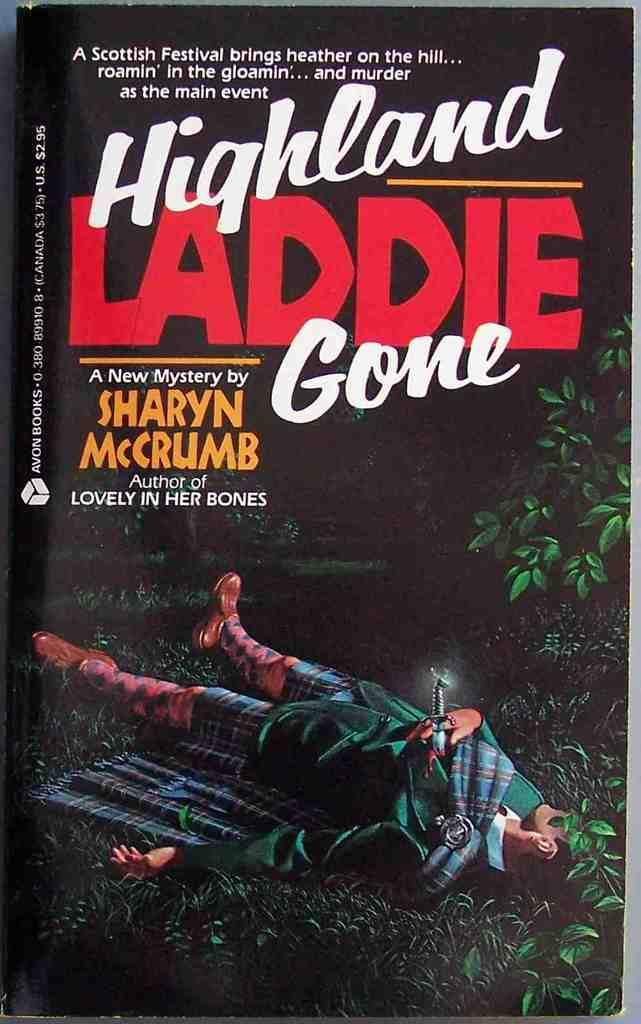Provide a one-sentence caption for the provided image. A book which is called Highland Laddie Gone. 